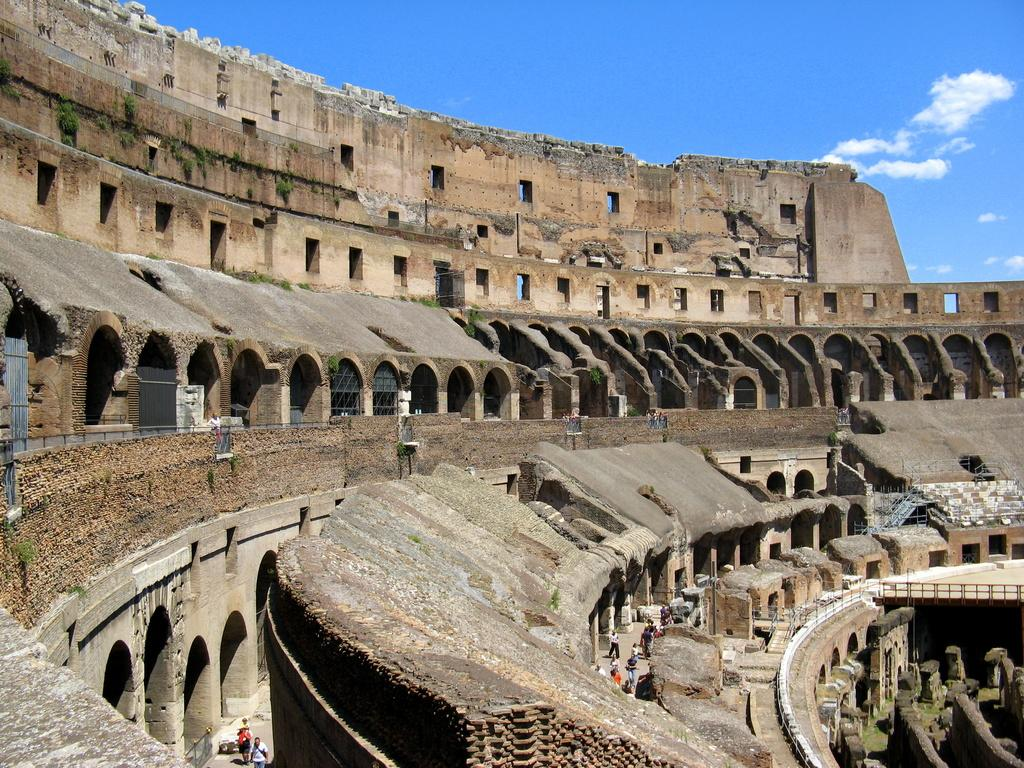What is the main subject of the image? The main subject of the image is a monument. Are there any people present in the image? Yes, there are people standing near the monument. What can be seen in the background of the image? The background of the image includes clouds. What is visible in the sky in the image? The sky is visible in the background of the image. What type of cactus can be seen growing near the monument in the image? There is no cactus present in the image; it features a monument with people standing nearby and a cloudy sky in the background. 